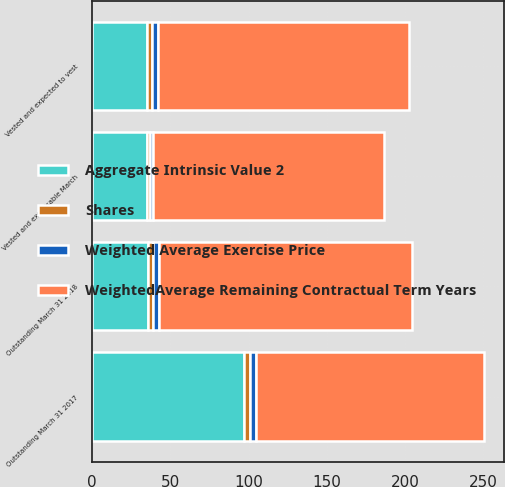Convert chart. <chart><loc_0><loc_0><loc_500><loc_500><stacked_bar_chart><ecel><fcel>Outstanding March 31 2017<fcel>Outstanding March 31 2018<fcel>Vested and expected to vest<fcel>Vested and exercisable March<nl><fcel>Shares<fcel>4<fcel>3<fcel>3<fcel>2<nl><fcel>WeightedAverage Remaining Contractual Term Years<fcel>145.76<fcel>161.27<fcel>160.28<fcel>147.76<nl><fcel>Weighted Average Exercise Price<fcel>4<fcel>4<fcel>4<fcel>2<nl><fcel>Aggregate Intrinsic Value 2<fcel>97<fcel>36<fcel>35<fcel>35<nl></chart> 